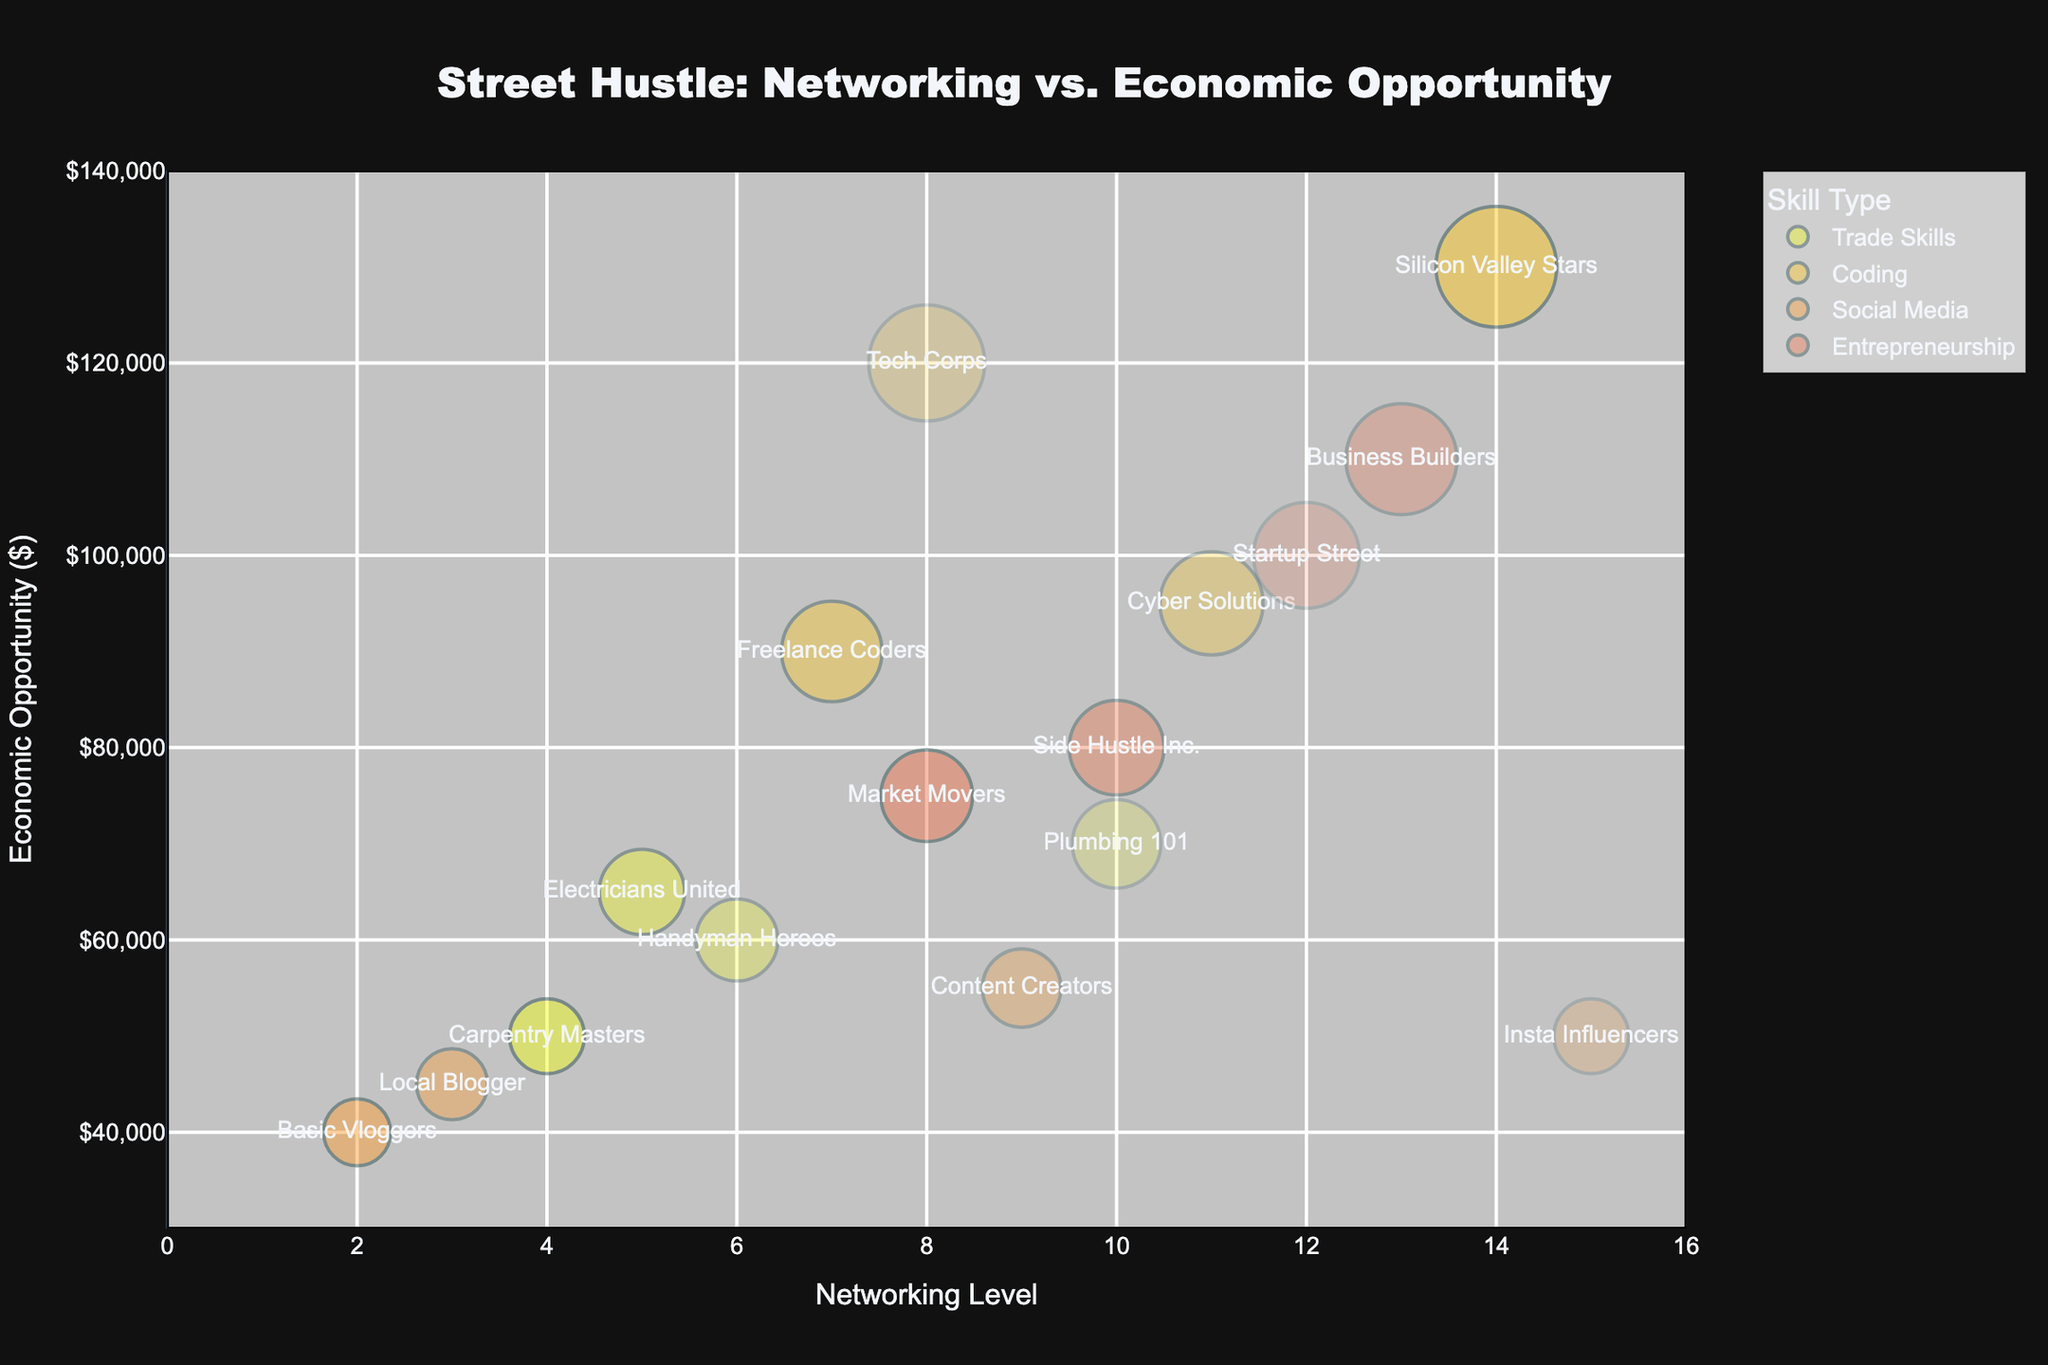What's the title of the figure? The title is displayed at the top of the figure, centered above the chart. It reads "Street Hustle: Networking vs. Economic Opportunity."
Answer: Street Hustle: Networking vs. Economic Opportunity How many skill types are represented in the figure? The legend to the right of the chart lists the different skill types. There are five distinct skill types: Trade Skills, Coding, Social Media, Entrepreneurship, and Coding.
Answer: 4 Which entity generates the highest economic opportunity? The bubble positioned at the highest point on the y-axis represents the entity with the highest economic opportunity. That entity is "Silicon Valley Stars" with an economic opportunity of $130,000.
Answer: Silicon Valley Stars What is the networking level and economic opportunity of "Side Hustle Inc."? The bubbles have labels that provide the entity names. Locate the bubble for "Side Hustle Inc." to find its position on the x and y axes. It has a networking level of 10 and an economic opportunity of $80,000.
Answer: Networking level: 10, Economic opportunity: $80,000 Which skill type has the most diverse range of networking levels? Examine the spread of bubbles along the x-axis for each skill type using different colors. Coding spreads widely from 7 to 14, making it the skill type with the most diverse range of networking levels.
Answer: Coding What's the average economic opportunity for entities with a networking level of 10? Identify the bubbles at networking level 10 and average their economic opportunities. The entities are "Plumbing 101" ($70,000) and "Side Hustle Inc." ($80,000). Average: (70,000 + 80,000) / 2 = $75,000
Answer: $75,000 What do the transparency levels indicate in the figure? In the figure, transparency levels of the bubbles are represented by the value in the column "Transparency." A lower value means a more transparent bubble, while a higher value indicates a more opaque bubble.
Answer: Transparency levels indicate bubble opacity Which entity has the lowest economic opportunity, and what is its transparency level? Look for the bubble at the lowest point on the y-axis. "Basic Vloggers" has the lowest economic opportunity at $40,000, with a transparency level of 0.7.
Answer: Basic Vloggers, Transparency level: 0.7 How do economic opportunities compare between "Freelance Coders" and "Cyber Solutions"? Locate the bubbles for "Freelance Coders" ($90,000) and "Cyber Solutions" ($95,000) along the y-axis. Compare these values to see that "Cyber Solutions" offers a higher economic opportunity by $5,000.
Answer: "Cyber Solutions" offers higher economic opportunity by $5,000 What's the relationship between networking level and economic opportunity for entities within "Entrepreneurship"? Observe the bubbles labeled "Entrepreneurship" along both the x and y axes. Higher networking levels generally correspond to higher economic opportunities, seen in entities like "Business Builders" and "Startup Street."
Answer: Higher networking levels relate to higher economic opportunities within "Entrepreneurship." 